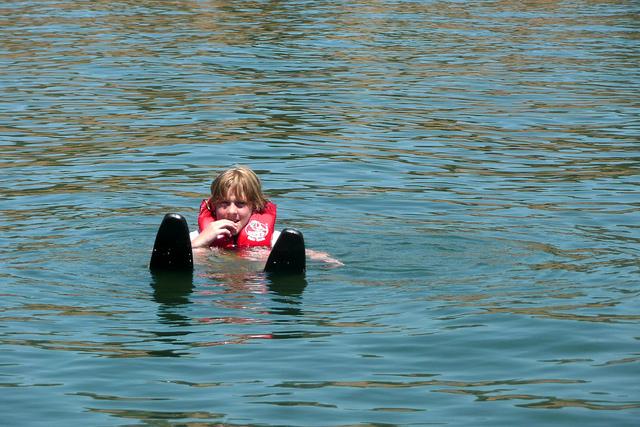What is on the child shoulder?
Quick response, please. Life jacket. Is the boy's hair wet?
Give a very brief answer. No. What color is the life vest?
Give a very brief answer. Red. Is this child about to be eaten by a shark?
Be succinct. No. 